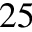<formula> <loc_0><loc_0><loc_500><loc_500>2 5</formula> 